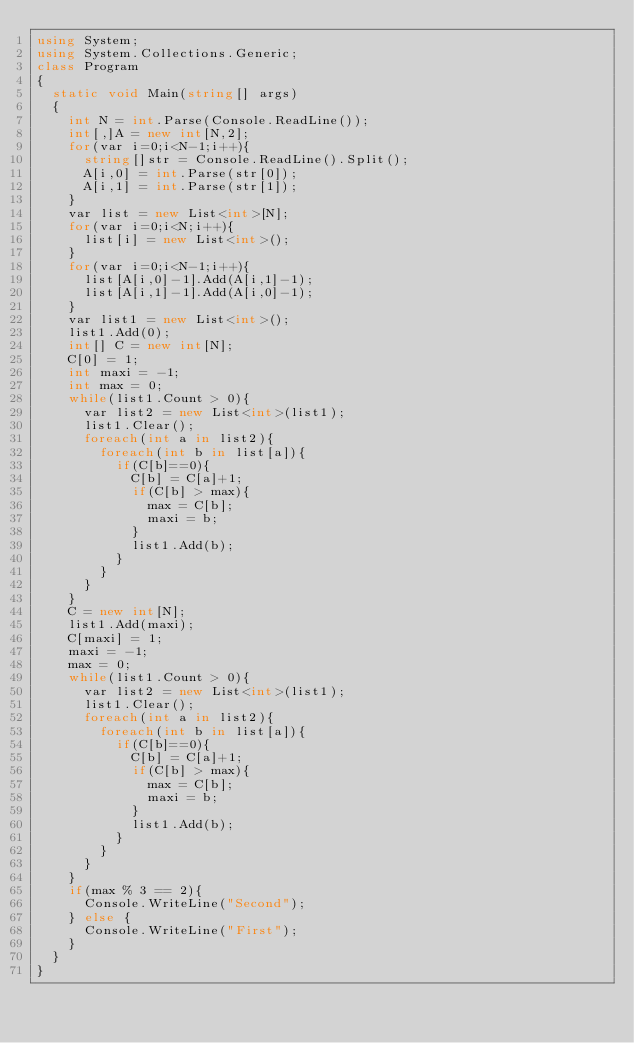<code> <loc_0><loc_0><loc_500><loc_500><_C#_>using System;
using System.Collections.Generic;
class Program
{
	static void Main(string[] args)
	{
		int N = int.Parse(Console.ReadLine());
		int[,]A = new int[N,2];
		for(var i=0;i<N-1;i++){
			string[]str = Console.ReadLine().Split();
			A[i,0] = int.Parse(str[0]);
			A[i,1] = int.Parse(str[1]);
		}
		var list = new List<int>[N];
		for(var i=0;i<N;i++){
			list[i] = new List<int>();
		}
		for(var i=0;i<N-1;i++){
			list[A[i,0]-1].Add(A[i,1]-1);
			list[A[i,1]-1].Add(A[i,0]-1);
		}
		var list1 = new List<int>();
		list1.Add(0);
		int[] C = new int[N];
		C[0] = 1;
		int maxi = -1;
		int max = 0;
		while(list1.Count > 0){
			var list2 = new List<int>(list1);
			list1.Clear();
			foreach(int a in list2){
				foreach(int b in list[a]){
					if(C[b]==0){
						C[b] = C[a]+1;
						if(C[b] > max){
							max = C[b];
							maxi = b;
						}
						list1.Add(b);
					}
				}
			}
		}
		C = new int[N];
		list1.Add(maxi);
		C[maxi] = 1;
		maxi = -1;
		max = 0;
		while(list1.Count > 0){
			var list2 = new List<int>(list1);
			list1.Clear();
			foreach(int a in list2){
				foreach(int b in list[a]){
					if(C[b]==0){
						C[b] = C[a]+1;
						if(C[b] > max){
							max = C[b];
							maxi = b;
						}
						list1.Add(b);
					}
				}
			}
		}
		if(max % 3 == 2){
			Console.WriteLine("Second");
		} else {
			Console.WriteLine("First");
		}
	}
}</code> 